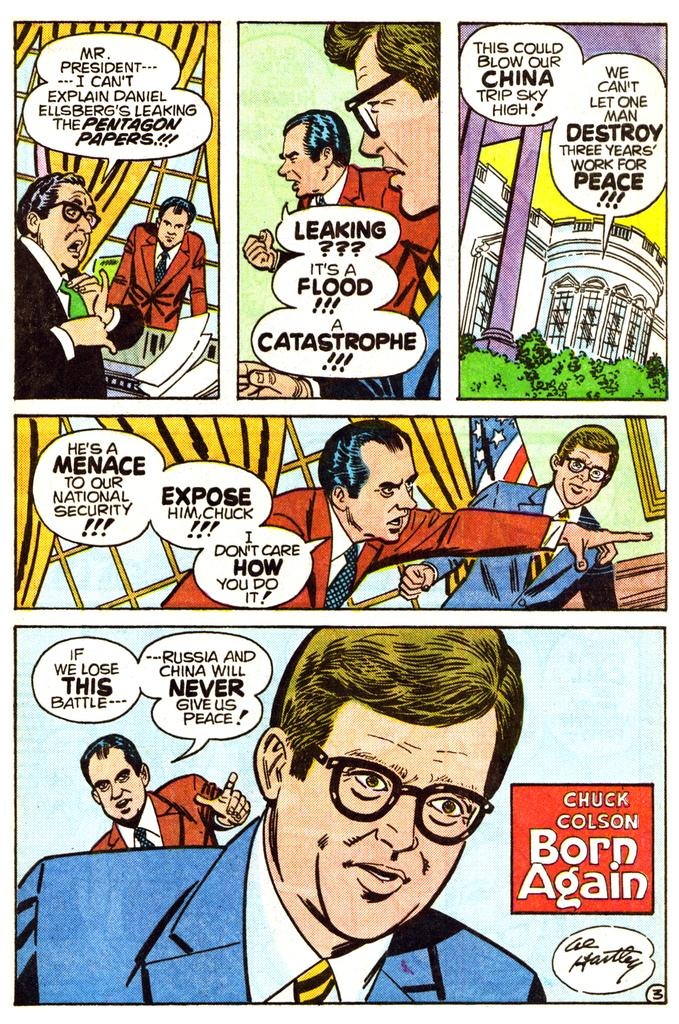What is the main subject in the center of the image? There is a poster in the center of the image. What can be seen on the poster? The poster contains images of people and objects. Is there any text on the poster? Yes, there is text on the poster. What grade is the land in the image? There is no land present in the image; it features a poster with images of people and objects. 